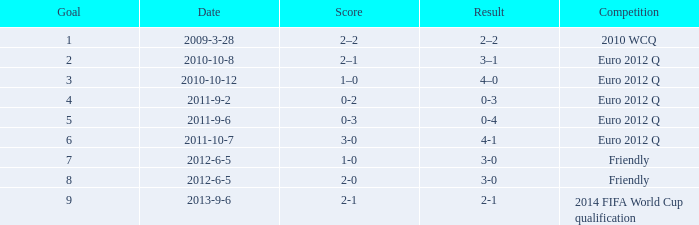What is the result when the score is 0-2? 0-3. 